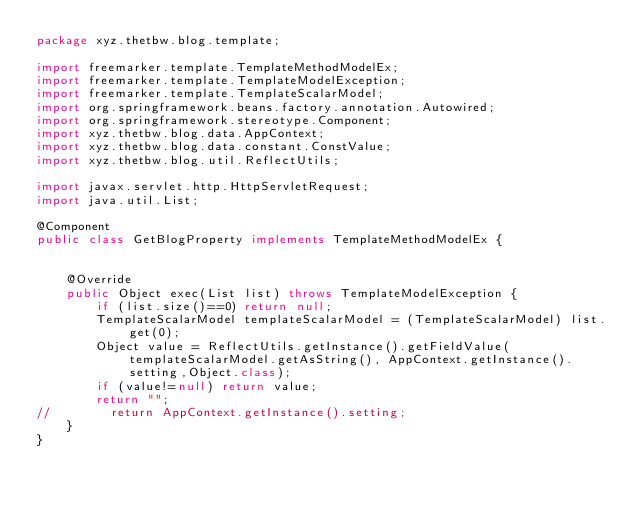Convert code to text. <code><loc_0><loc_0><loc_500><loc_500><_Java_>package xyz.thetbw.blog.template;

import freemarker.template.TemplateMethodModelEx;
import freemarker.template.TemplateModelException;
import freemarker.template.TemplateScalarModel;
import org.springframework.beans.factory.annotation.Autowired;
import org.springframework.stereotype.Component;
import xyz.thetbw.blog.data.AppContext;
import xyz.thetbw.blog.data.constant.ConstValue;
import xyz.thetbw.blog.util.ReflectUtils;

import javax.servlet.http.HttpServletRequest;
import java.util.List;

@Component
public class GetBlogProperty implements TemplateMethodModelEx {


    @Override
    public Object exec(List list) throws TemplateModelException {
        if (list.size()==0) return null;
        TemplateScalarModel templateScalarModel = (TemplateScalarModel) list.get(0);
        Object value = ReflectUtils.getInstance().getFieldValue(templateScalarModel.getAsString(), AppContext.getInstance().setting,Object.class);
        if (value!=null) return value;
        return "";
//        return AppContext.getInstance().setting;
    }
}
</code> 